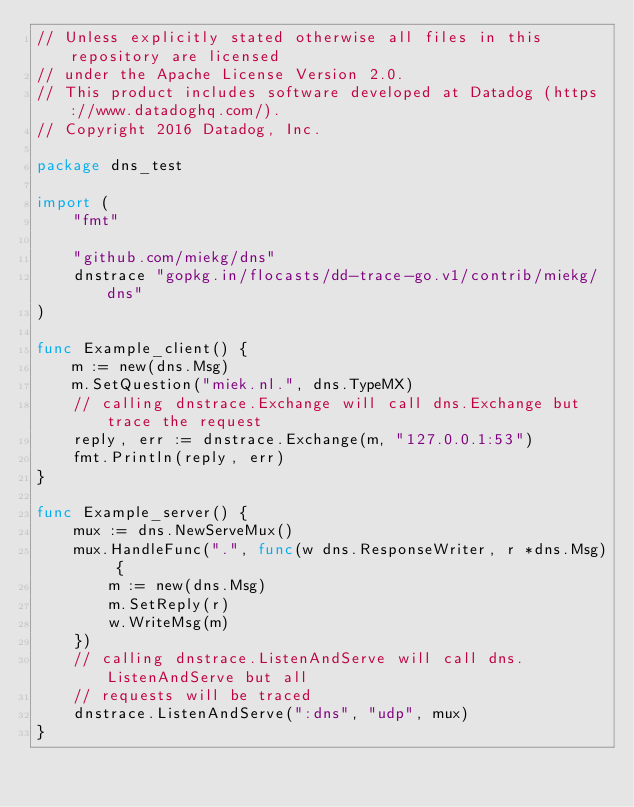Convert code to text. <code><loc_0><loc_0><loc_500><loc_500><_Go_>// Unless explicitly stated otherwise all files in this repository are licensed
// under the Apache License Version 2.0.
// This product includes software developed at Datadog (https://www.datadoghq.com/).
// Copyright 2016 Datadog, Inc.

package dns_test

import (
	"fmt"

	"github.com/miekg/dns"
	dnstrace "gopkg.in/flocasts/dd-trace-go.v1/contrib/miekg/dns"
)

func Example_client() {
	m := new(dns.Msg)
	m.SetQuestion("miek.nl.", dns.TypeMX)
	// calling dnstrace.Exchange will call dns.Exchange but trace the request
	reply, err := dnstrace.Exchange(m, "127.0.0.1:53")
	fmt.Println(reply, err)
}

func Example_server() {
	mux := dns.NewServeMux()
	mux.HandleFunc(".", func(w dns.ResponseWriter, r *dns.Msg) {
		m := new(dns.Msg)
		m.SetReply(r)
		w.WriteMsg(m)
	})
	// calling dnstrace.ListenAndServe will call dns.ListenAndServe but all
	// requests will be traced
	dnstrace.ListenAndServe(":dns", "udp", mux)
}
</code> 